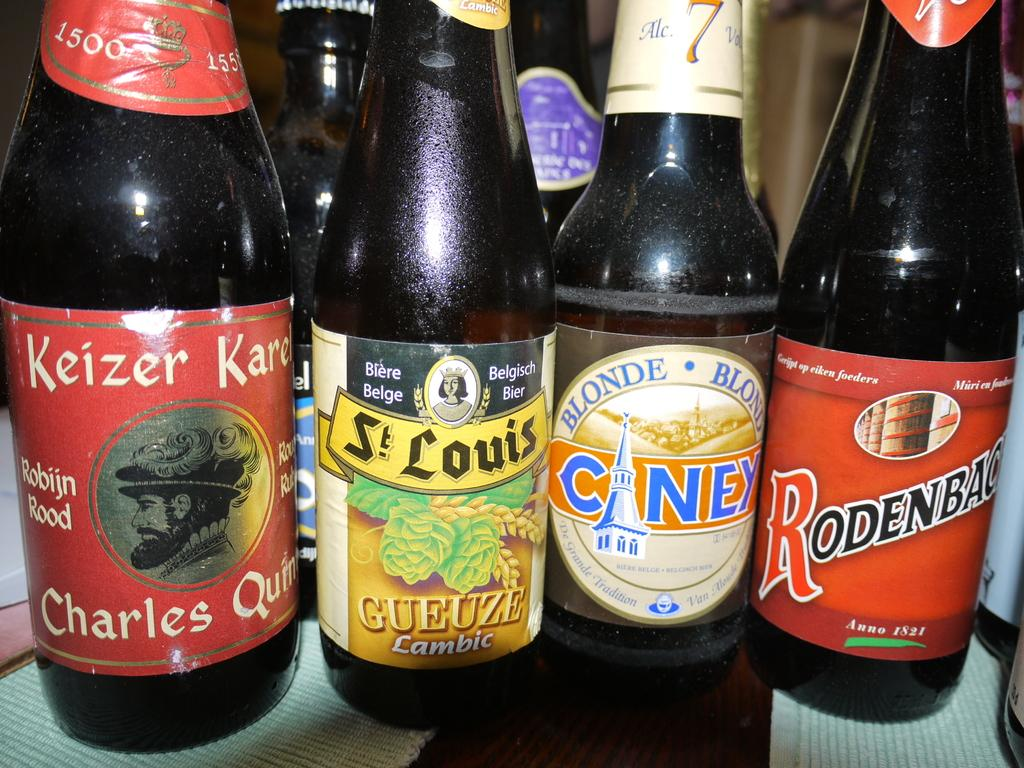<image>
Give a short and clear explanation of the subsequent image. Dark bottles of different drinks are on the shelf starting with a bottle of "Keizer Karel". 